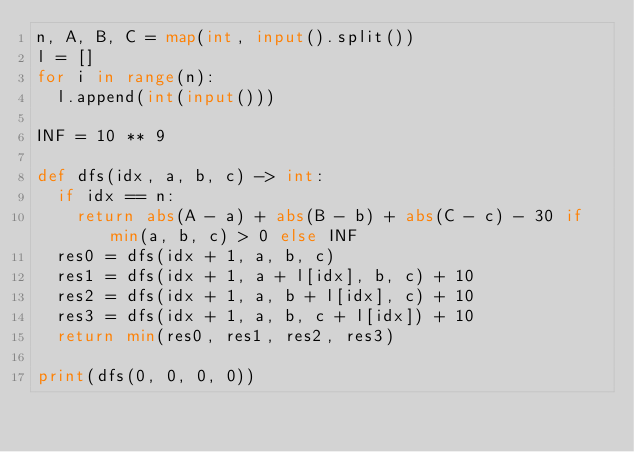Convert code to text. <code><loc_0><loc_0><loc_500><loc_500><_Python_>n, A, B, C = map(int, input().split())
l = []
for i in range(n):
	l.append(int(input()))

INF = 10 ** 9

def dfs(idx, a, b, c) -> int:
	if idx == n:
		return abs(A - a) + abs(B - b) + abs(C - c) - 30 if min(a, b, c) > 0 else INF
	res0 = dfs(idx + 1, a, b, c)
	res1 = dfs(idx + 1, a + l[idx], b, c) + 10
	res2 = dfs(idx + 1, a, b + l[idx], c) + 10
	res3 = dfs(idx + 1, a, b, c + l[idx]) + 10
	return min(res0, res1, res2, res3)

print(dfs(0, 0, 0, 0))</code> 